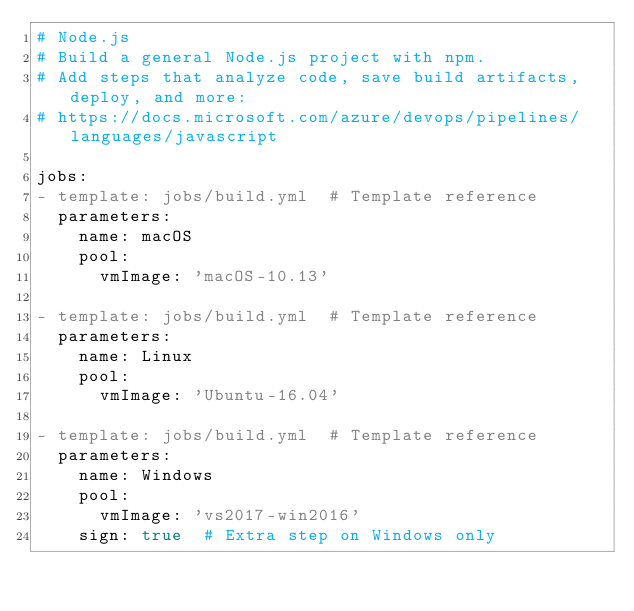Convert code to text. <code><loc_0><loc_0><loc_500><loc_500><_YAML_># Node.js
# Build a general Node.js project with npm.
# Add steps that analyze code, save build artifacts, deploy, and more:
# https://docs.microsoft.com/azure/devops/pipelines/languages/javascript

jobs:
- template: jobs/build.yml  # Template reference
  parameters:
    name: macOS
    pool:
      vmImage: 'macOS-10.13'

- template: jobs/build.yml  # Template reference
  parameters:
    name: Linux
    pool:
      vmImage: 'Ubuntu-16.04'

- template: jobs/build.yml  # Template reference
  parameters:
    name: Windows
    pool:
      vmImage: 'vs2017-win2016'
    sign: true  # Extra step on Windows only
</code> 